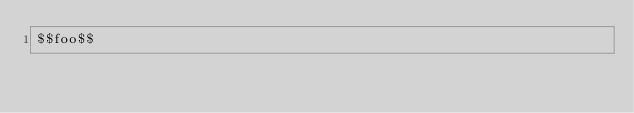<code> <loc_0><loc_0><loc_500><loc_500><_HTML_>$$foo$$</code> 